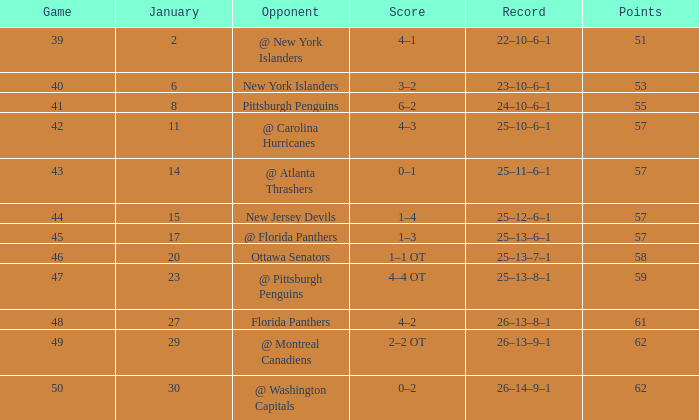What is the average for january with points of 51 2.0. Write the full table. {'header': ['Game', 'January', 'Opponent', 'Score', 'Record', 'Points'], 'rows': [['39', '2', '@ New York Islanders', '4–1', '22–10–6–1', '51'], ['40', '6', 'New York Islanders', '3–2', '23–10–6–1', '53'], ['41', '8', 'Pittsburgh Penguins', '6–2', '24–10–6–1', '55'], ['42', '11', '@ Carolina Hurricanes', '4–3', '25–10–6–1', '57'], ['43', '14', '@ Atlanta Thrashers', '0–1', '25–11–6–1', '57'], ['44', '15', 'New Jersey Devils', '1–4', '25–12–6–1', '57'], ['45', '17', '@ Florida Panthers', '1–3', '25–13–6–1', '57'], ['46', '20', 'Ottawa Senators', '1–1 OT', '25–13–7–1', '58'], ['47', '23', '@ Pittsburgh Penguins', '4–4 OT', '25–13–8–1', '59'], ['48', '27', 'Florida Panthers', '4–2', '26–13–8–1', '61'], ['49', '29', '@ Montreal Canadiens', '2–2 OT', '26–13–9–1', '62'], ['50', '30', '@ Washington Capitals', '0–2', '26–14–9–1', '62']]} 